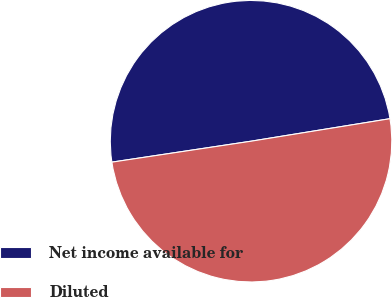<chart> <loc_0><loc_0><loc_500><loc_500><pie_chart><fcel>Net income available for<fcel>Diluted<nl><fcel>49.82%<fcel>50.18%<nl></chart> 